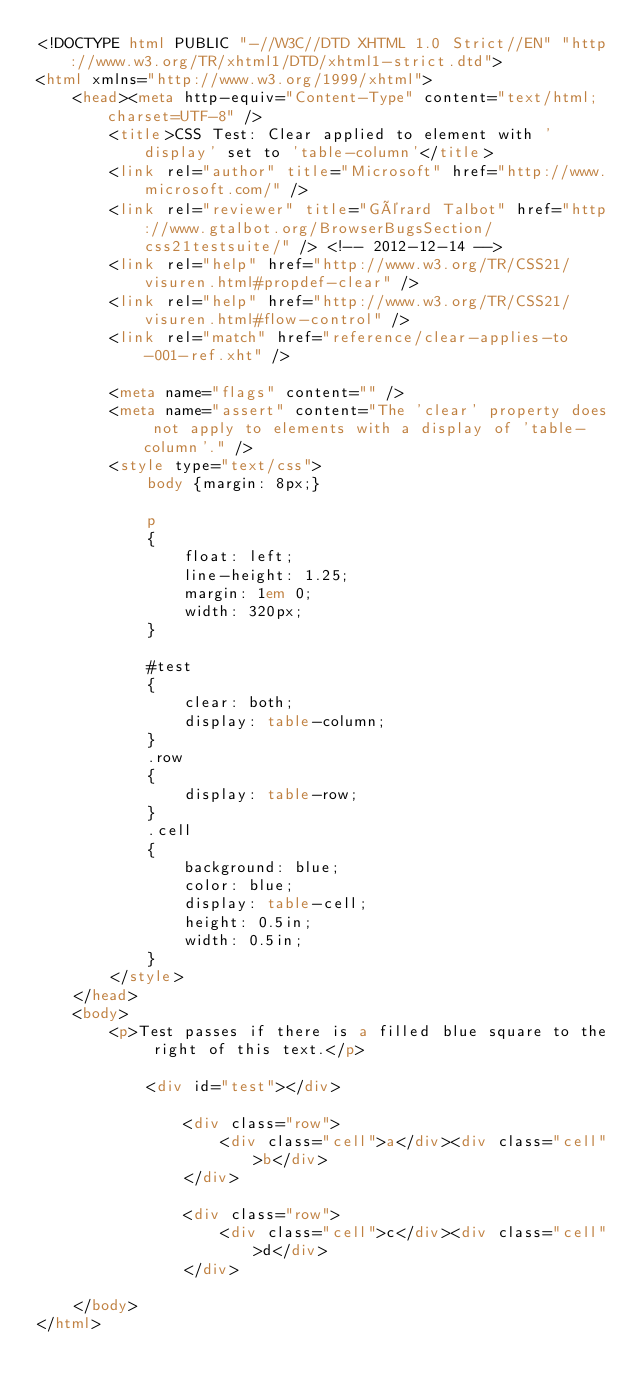<code> <loc_0><loc_0><loc_500><loc_500><_HTML_><!DOCTYPE html PUBLIC "-//W3C//DTD XHTML 1.0 Strict//EN" "http://www.w3.org/TR/xhtml1/DTD/xhtml1-strict.dtd">
<html xmlns="http://www.w3.org/1999/xhtml">
    <head><meta http-equiv="Content-Type" content="text/html; charset=UTF-8" />
        <title>CSS Test: Clear applied to element with 'display' set to 'table-column'</title>
        <link rel="author" title="Microsoft" href="http://www.microsoft.com/" />
        <link rel="reviewer" title="Gérard Talbot" href="http://www.gtalbot.org/BrowserBugsSection/css21testsuite/" /> <!-- 2012-12-14 -->
        <link rel="help" href="http://www.w3.org/TR/CSS21/visuren.html#propdef-clear" />
        <link rel="help" href="http://www.w3.org/TR/CSS21/visuren.html#flow-control" />
        <link rel="match" href="reference/clear-applies-to-001-ref.xht" />

        <meta name="flags" content="" />
        <meta name="assert" content="The 'clear' property does not apply to elements with a display of 'table-column'." />
        <style type="text/css">
            body {margin: 8px;}

            p
            {
                float: left;
                line-height: 1.25;
                margin: 1em 0;
                width: 320px;
            }

            #test
            {
                clear: both;
                display: table-column;
            }
            .row
            {
                display: table-row;
            }
            .cell
            {
                background: blue;
                color: blue;
                display: table-cell;
                height: 0.5in;
                width: 0.5in;
            }
        </style>
    </head>
    <body>
        <p>Test passes if there is a filled blue square to the right of this text.</p>

            <div id="test"></div>

                <div class="row">
                    <div class="cell">a</div><div class="cell">b</div>
                </div>

                <div class="row">
                    <div class="cell">c</div><div class="cell">d</div>
                </div>

    </body>
</html></code> 